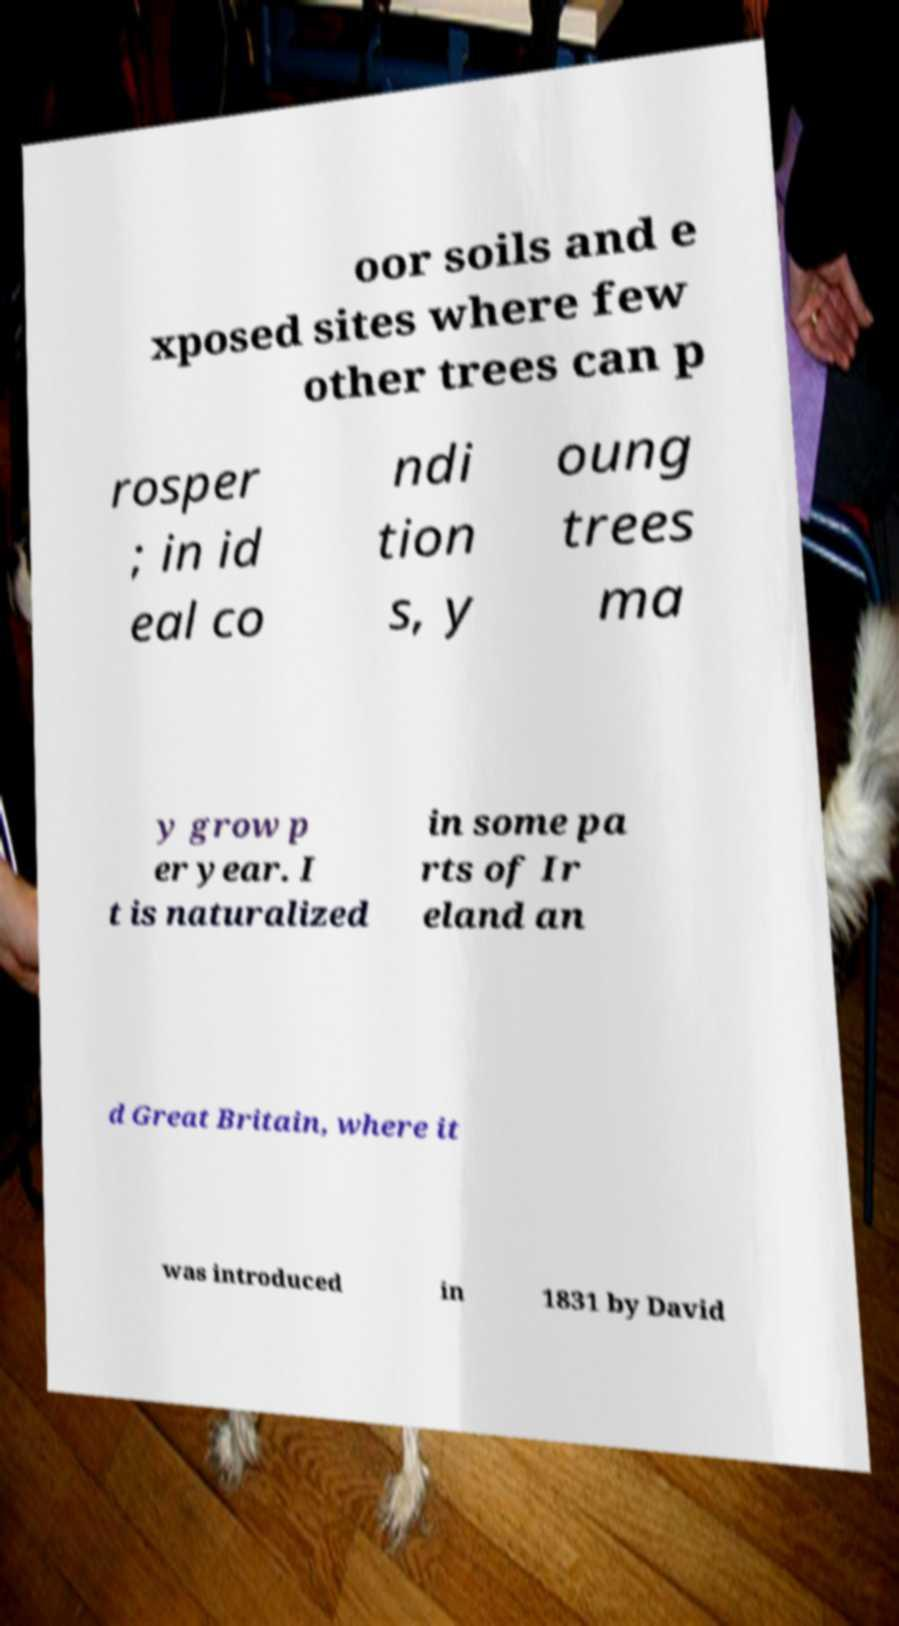What messages or text are displayed in this image? I need them in a readable, typed format. oor soils and e xposed sites where few other trees can p rosper ; in id eal co ndi tion s, y oung trees ma y grow p er year. I t is naturalized in some pa rts of Ir eland an d Great Britain, where it was introduced in 1831 by David 